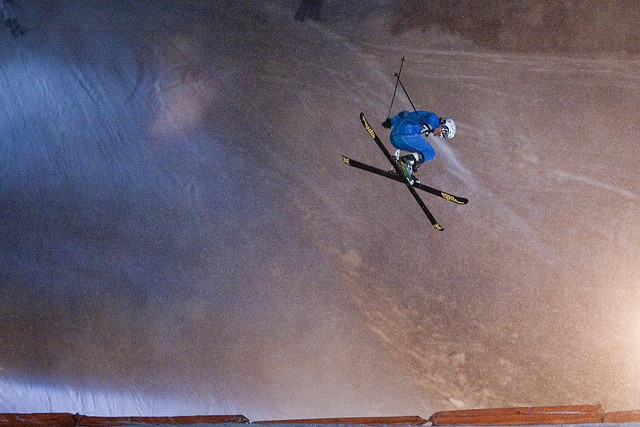Describe the objects in this image and their specific colors. I can see people in navy, blue, black, and gray tones and skis in navy, black, gray, and tan tones in this image. 